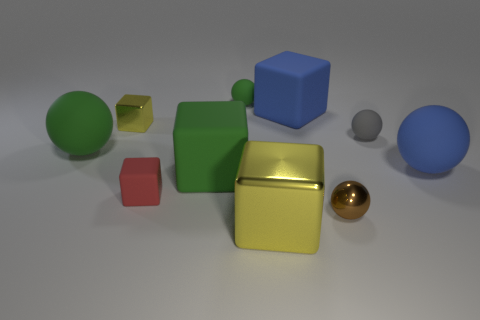Subtract 2 blocks. How many blocks are left? 3 Subtract all big green rubber blocks. How many blocks are left? 4 Subtract all blue blocks. How many blocks are left? 4 Subtract all yellow spheres. Subtract all brown cubes. How many spheres are left? 5 Add 7 tiny gray matte balls. How many tiny gray matte balls exist? 8 Subtract 0 green cylinders. How many objects are left? 10 Subtract all tiny brown spheres. Subtract all brown metallic objects. How many objects are left? 8 Add 8 large blue balls. How many large blue balls are left? 9 